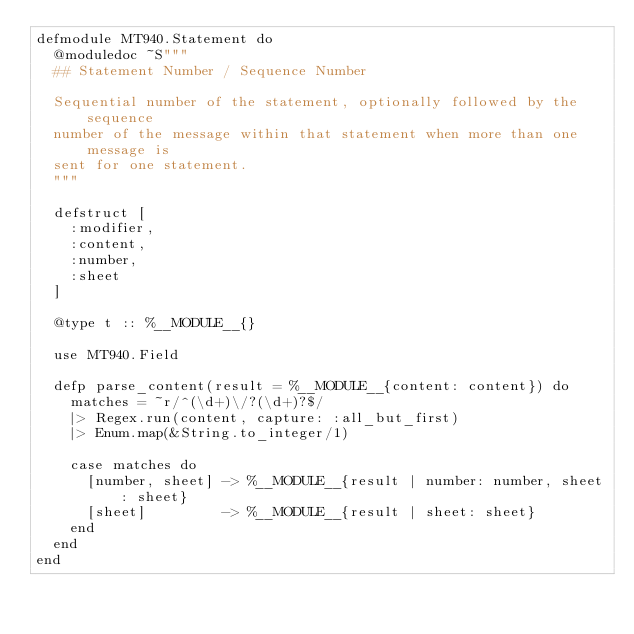<code> <loc_0><loc_0><loc_500><loc_500><_Elixir_>defmodule MT940.Statement do
  @moduledoc ~S"""
  ## Statement Number / Sequence Number

  Sequential number of the statement, optionally followed by the sequence
  number of the message within that statement when more than one message is
  sent for one statement.
  """

  defstruct [
    :modifier,
    :content,
    :number,
    :sheet
  ]

  @type t :: %__MODULE__{}

  use MT940.Field

  defp parse_content(result = %__MODULE__{content: content}) do
    matches = ~r/^(\d+)\/?(\d+)?$/
    |> Regex.run(content, capture: :all_but_first)
    |> Enum.map(&String.to_integer/1)

    case matches do
      [number, sheet] -> %__MODULE__{result | number: number, sheet: sheet}
      [sheet]         -> %__MODULE__{result | sheet: sheet}
    end
  end
end
</code> 